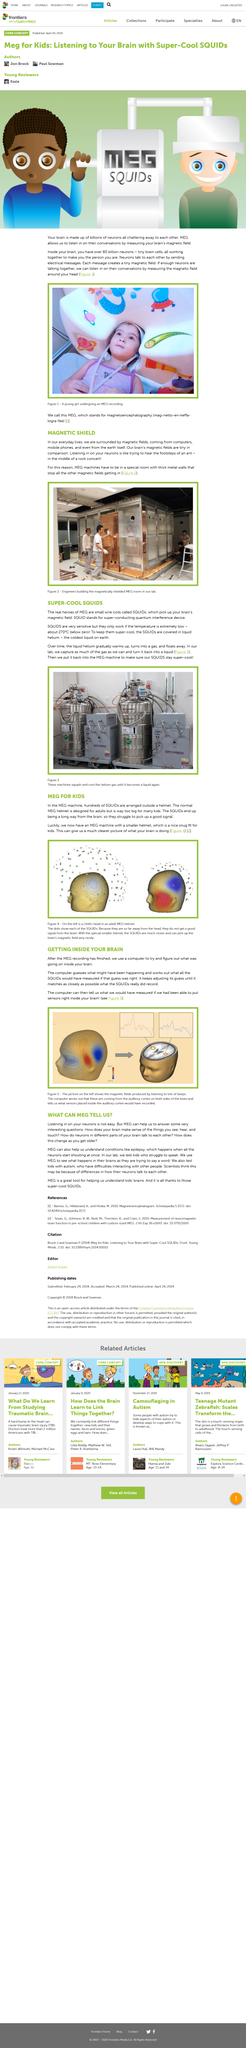Mention a couple of crucial points in this snapshot. MEG is a powerful neuroimaging tool that can accurately measure neuronal activity in the brain, providing valuable insights into the complex workings of brain function. The fields that we are surrounded by in our everyday lives include magnetic fields, which are prevalent in our environment. The normal MEG helmet is designed for adults and not for children. Magnetic fields are ubiquitous, originating from sources such as mobile phones, computers, and the Earth itself. In the MEG machine, the SQUIDs are arranged outside of a helmet, and there are hundreds of them. 